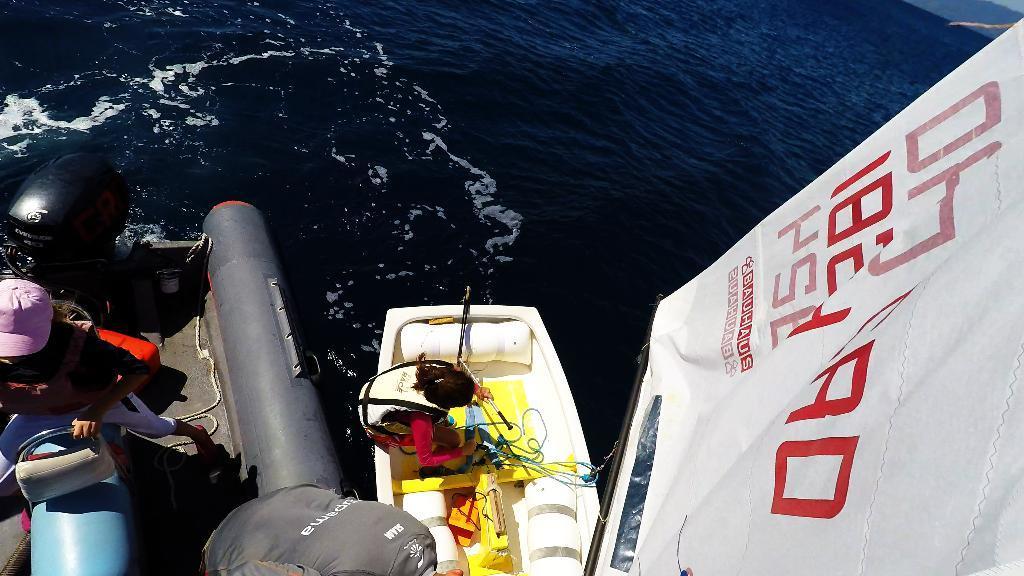Describe this image in one or two sentences. This is an ocean. At the bottom there is a boat. On the boat I can see a person is sitting and there are few objects. On the left side there is a metal object. It seems to be a part of another boat. On this few people are standing and there are many objects. On the right side there is a white color banner on which I can see some text. 